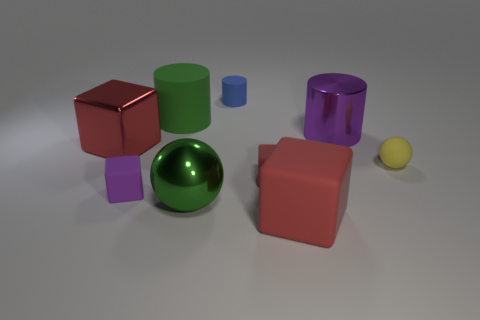Is the color of the large metallic block the same as the rubber block that is on the left side of the blue thing?
Provide a short and direct response. No. The other shiny object that is the same shape as the blue thing is what color?
Your answer should be very brief. Purple. Are the blue cylinder and the large red cube that is in front of the metallic block made of the same material?
Ensure brevity in your answer.  Yes. The big rubber cylinder is what color?
Give a very brief answer. Green. There is a large cylinder that is on the left side of the metal object that is right of the large red object in front of the small yellow ball; what color is it?
Keep it short and to the point. Green. There is a small blue rubber thing; does it have the same shape as the big green object that is behind the purple metallic cylinder?
Your answer should be very brief. Yes. What color is the cylinder that is both right of the large green sphere and in front of the blue thing?
Your answer should be compact. Purple. Are there any cyan matte things of the same shape as the large purple metallic object?
Give a very brief answer. No. Is the big metallic ball the same color as the small sphere?
Keep it short and to the point. No. There is a big green thing that is in front of the yellow matte sphere; are there any green matte cylinders in front of it?
Your answer should be compact. No. 